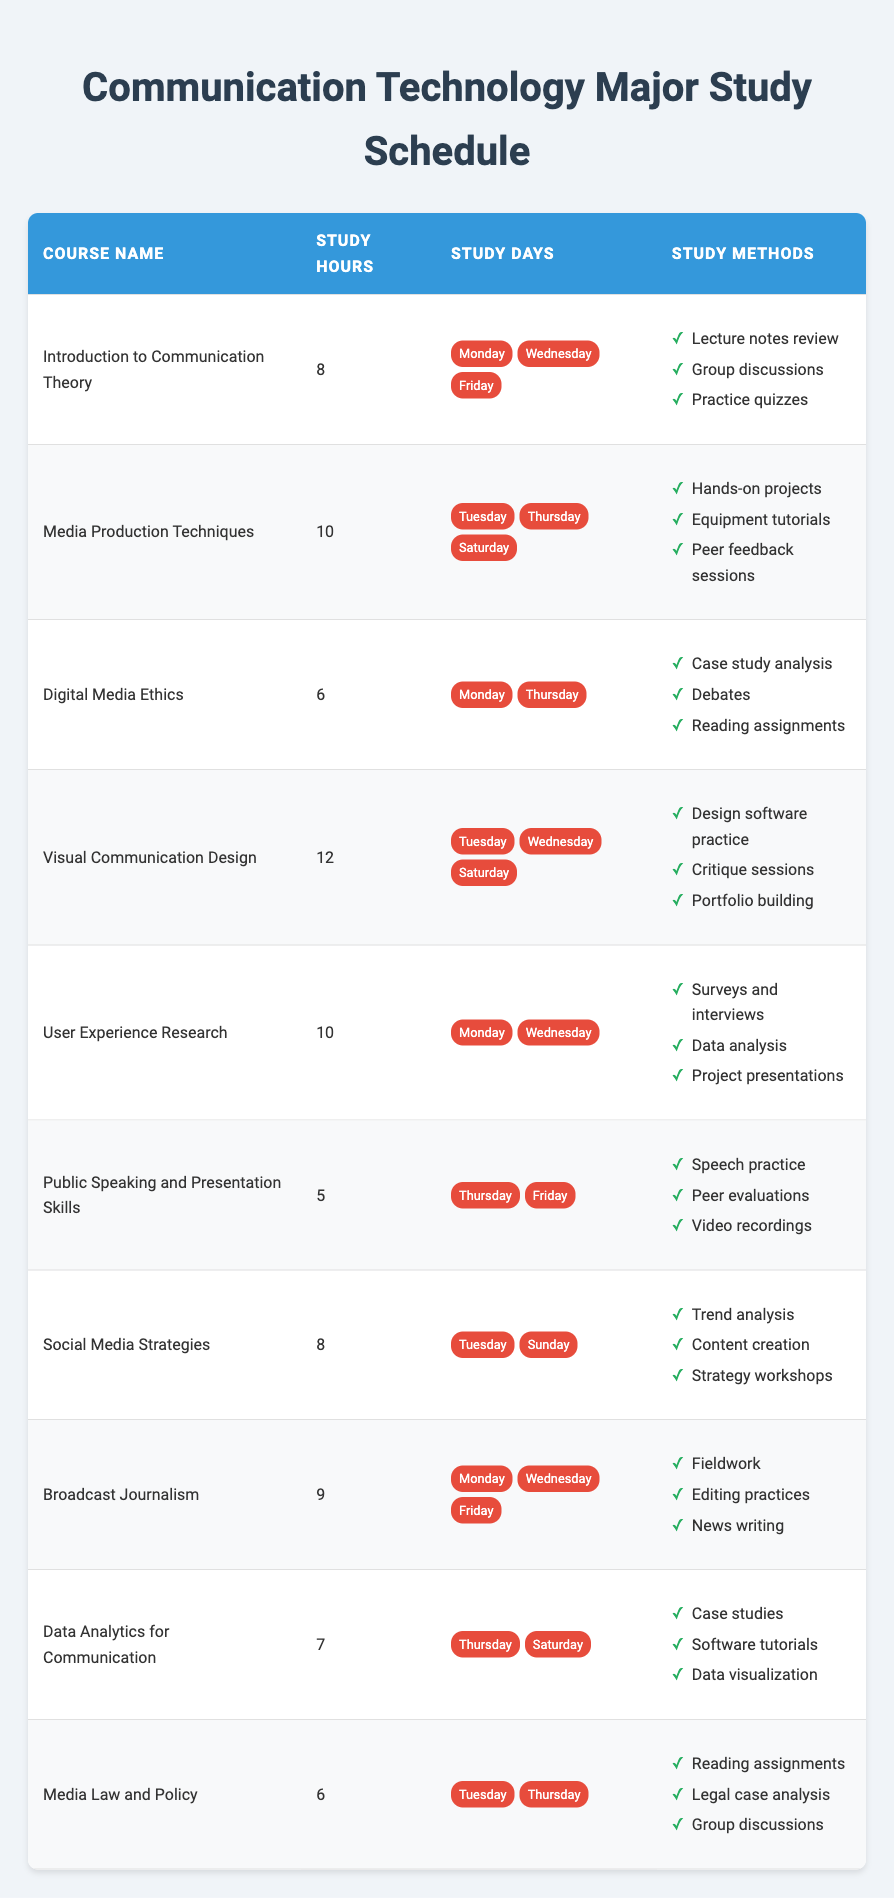What is the course with the highest study hours? By examining the "Study Hours" column, "Visual Communication Design" has the highest value of 12.
Answer: Visual Communication Design Which courses are studied on Wednesdays? Looking at the "Study Days" for each course, "Introduction to Communication Theory," "User Experience Research," "Broadcast Journalism," and "Visual Communication Design" all list Wednesday as a study day.
Answer: Introduction to Communication Theory, User Experience Research, Broadcast Journalism, Visual Communication Design What is the average study hours for all courses? To find the average, sum the study hours: (8 + 10 + 6 + 12 + 10 + 5 + 8 + 9 + 7 + 6) = 81. There are 10 courses, so the average is 81 / 10 = 8.1.
Answer: 8.1 Does "Media Production Techniques" have a study day on Sunday? Checking the study days for "Media Production Techniques," it lists Tuesday, Thursday, and Saturday, which means Sunday is not a study day.
Answer: No How many courses have a study method that includes "practice"? Analyzing the study methods, "Introduction to Communication Theory," "Visual Communication Design," "Public Speaking and Presentation Skills," and "Broadcast Journalism" all have a method related to practice (like practice quizzes or speech practice). This totals to four courses.
Answer: 4 Which course has the least number of study hours and what are its methods? The course with the least study hours is "Public Speaking and Presentation Skills" with 5 hours. Its study methods are "Speech practice," "Peer evaluations," and "Video recordings."
Answer: Public Speaking and Presentation Skills, Speech practice, Peer evaluations, Video recordings Are there any courses that share the same study methods? Upon comparing the study methods for each course, there are no courses that share identical combinations of study methods. Each course has unique methods tailored to its content.
Answer: No Which courses are studied on both Thursdays and Tuesdays? Checking the schedules, "Media Law and Policy" and "Media Production Techniques" are the only courses that have study days on both Tuesday and Thursday.
Answer: Media Law and Policy, Media Production Techniques 